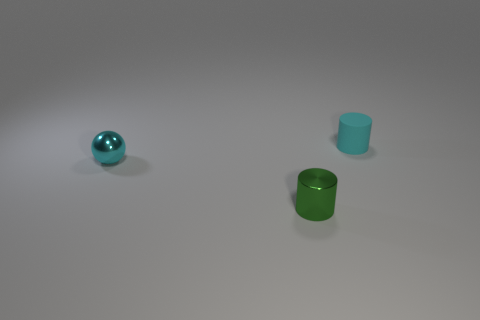Subtract 1 cylinders. How many cylinders are left? 1 Add 2 tiny gray rubber spheres. How many objects exist? 5 Subtract 0 gray cubes. How many objects are left? 3 Subtract all cylinders. How many objects are left? 1 Subtract all red balls. Subtract all purple cylinders. How many balls are left? 1 Subtract all large red cylinders. Subtract all tiny green metal cylinders. How many objects are left? 2 Add 3 shiny cylinders. How many shiny cylinders are left? 4 Add 3 tiny shiny things. How many tiny shiny things exist? 5 